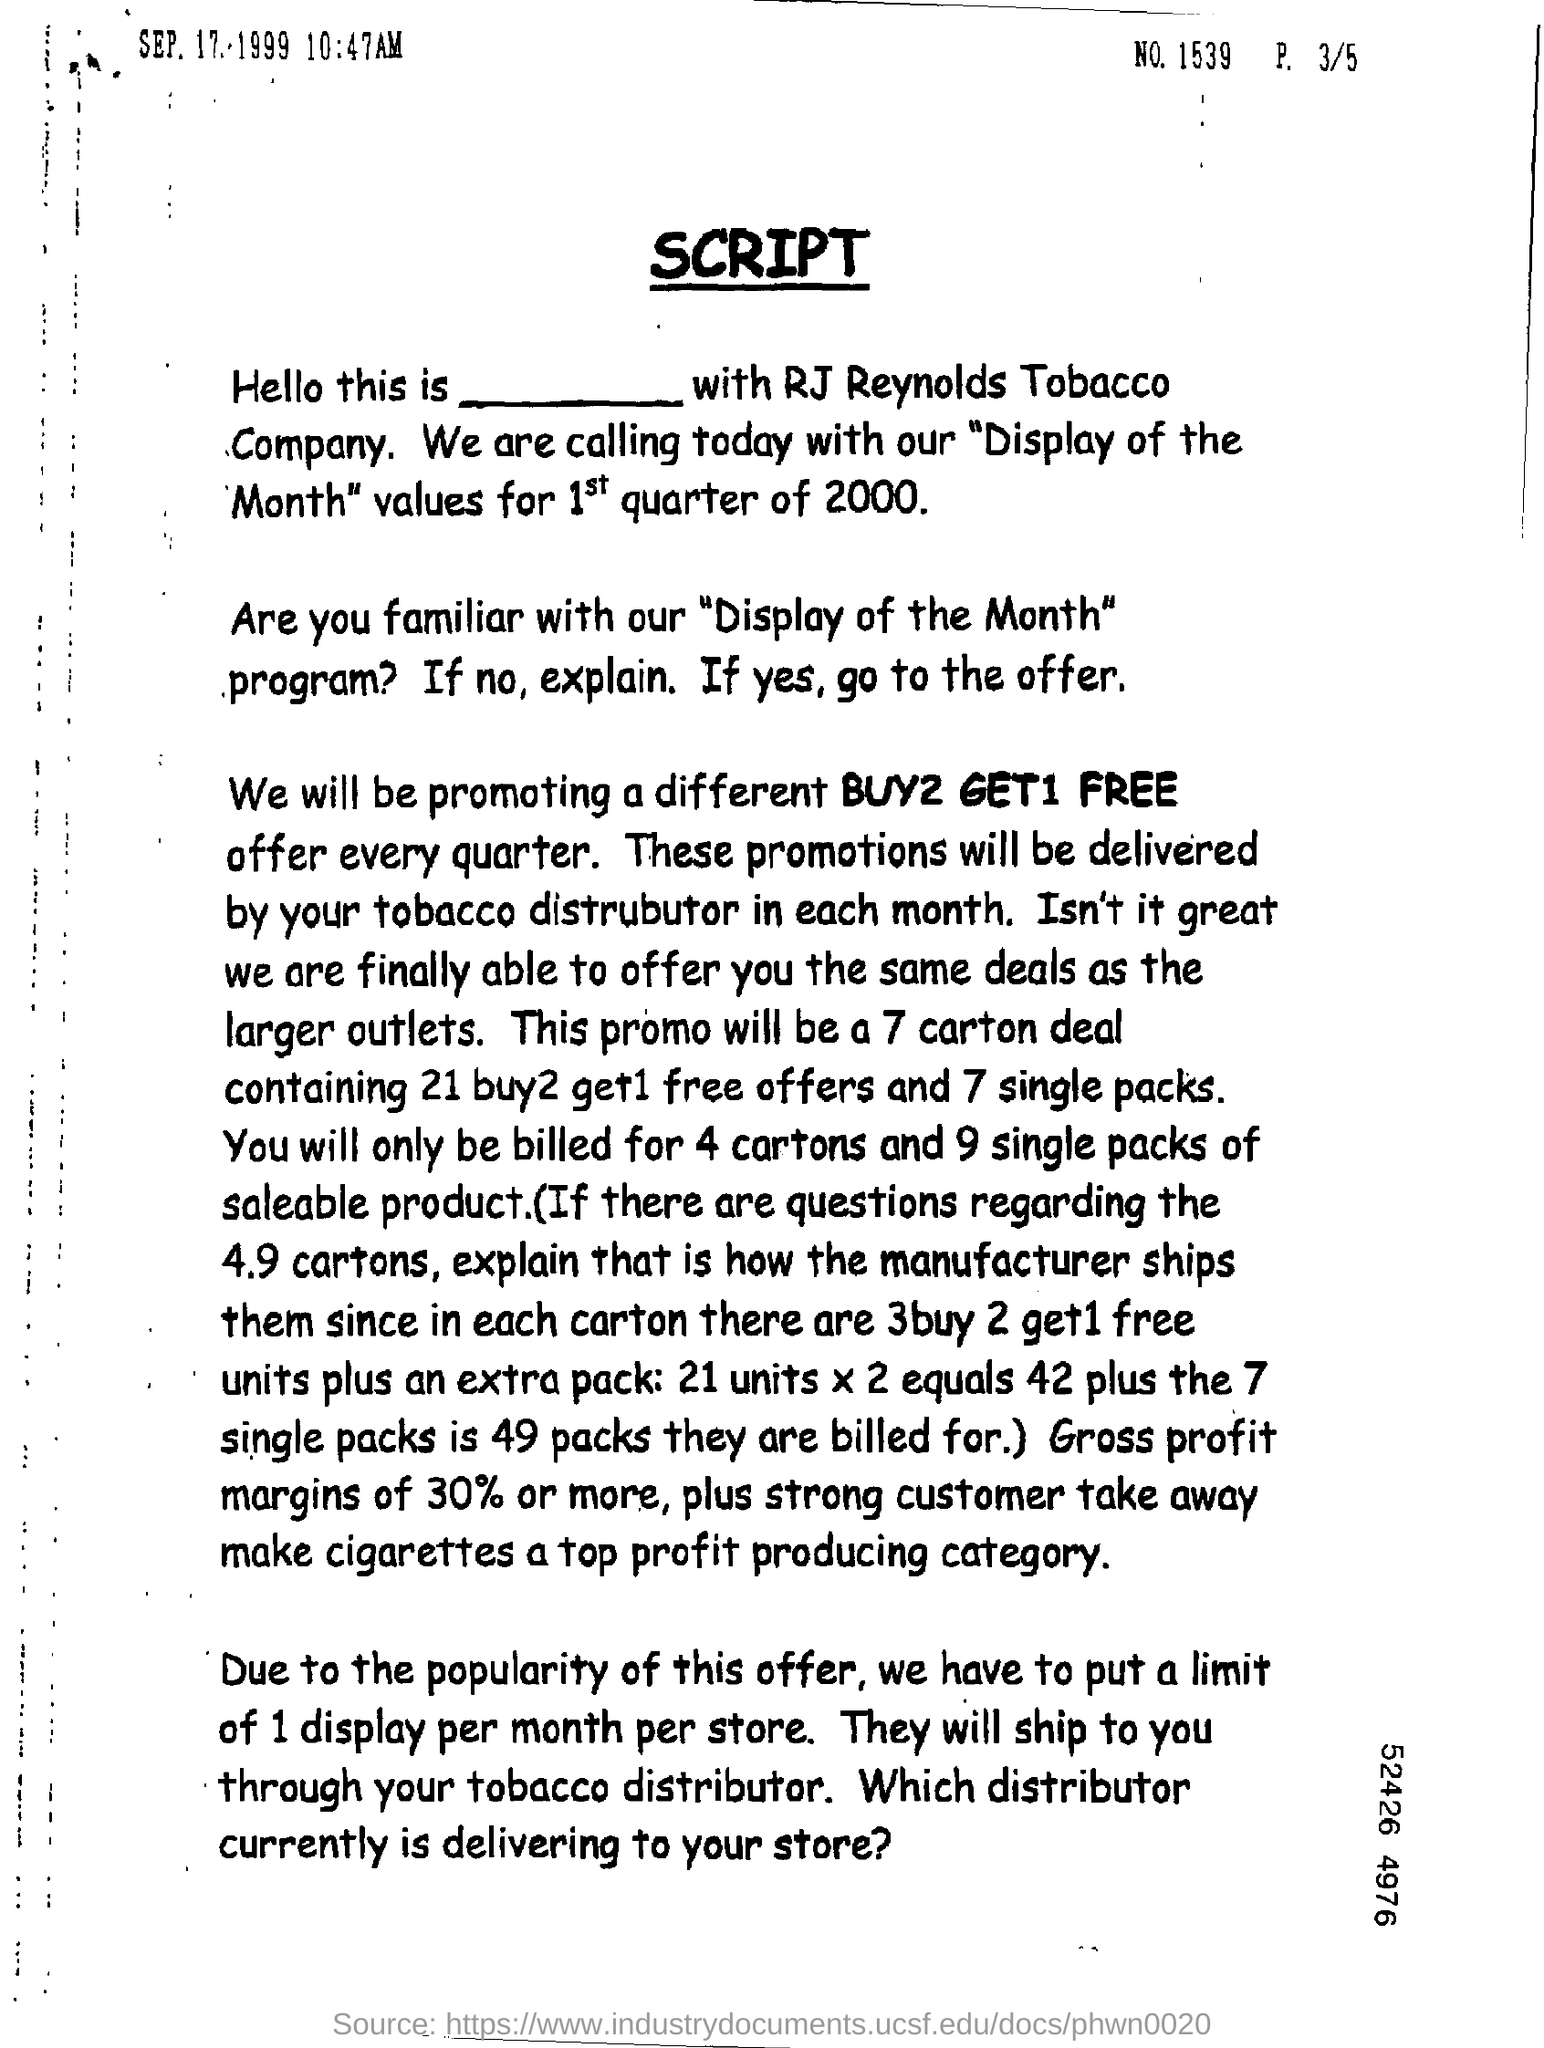What is the No. mentioned in the document?
Provide a succinct answer. 1539. What is the date & time given in the document?
Keep it short and to the point. SEP. 17/1999 10:47AM. 